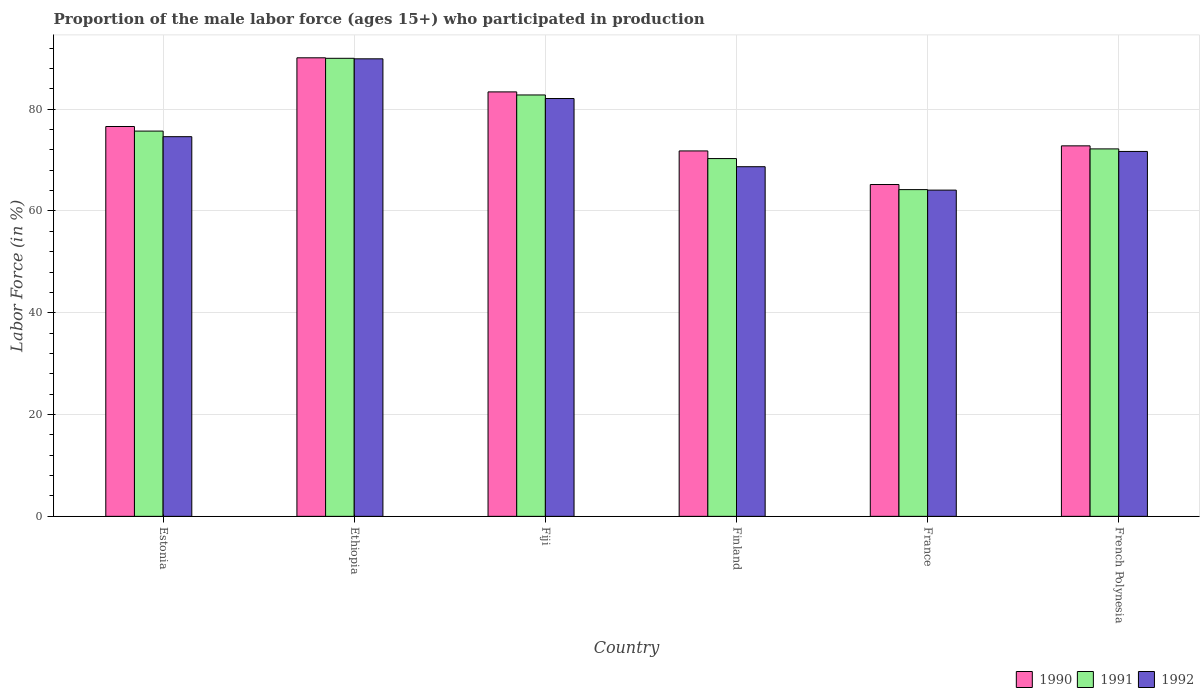What is the proportion of the male labor force who participated in production in 1991 in Finland?
Your answer should be very brief. 70.3. Across all countries, what is the maximum proportion of the male labor force who participated in production in 1992?
Your answer should be compact. 89.9. Across all countries, what is the minimum proportion of the male labor force who participated in production in 1992?
Your answer should be very brief. 64.1. In which country was the proportion of the male labor force who participated in production in 1992 maximum?
Give a very brief answer. Ethiopia. In which country was the proportion of the male labor force who participated in production in 1991 minimum?
Give a very brief answer. France. What is the total proportion of the male labor force who participated in production in 1992 in the graph?
Give a very brief answer. 451.1. What is the difference between the proportion of the male labor force who participated in production in 1990 in Fiji and that in Finland?
Your answer should be compact. 11.6. What is the difference between the proportion of the male labor force who participated in production in 1991 in Fiji and the proportion of the male labor force who participated in production in 1992 in French Polynesia?
Your answer should be compact. 11.1. What is the average proportion of the male labor force who participated in production in 1992 per country?
Offer a very short reply. 75.18. What is the difference between the proportion of the male labor force who participated in production of/in 1992 and proportion of the male labor force who participated in production of/in 1991 in France?
Your answer should be very brief. -0.1. In how many countries, is the proportion of the male labor force who participated in production in 1990 greater than 68 %?
Your answer should be very brief. 5. What is the ratio of the proportion of the male labor force who participated in production in 1990 in Ethiopia to that in Finland?
Your response must be concise. 1.25. Is the proportion of the male labor force who participated in production in 1990 in France less than that in French Polynesia?
Offer a terse response. Yes. Is the difference between the proportion of the male labor force who participated in production in 1992 in Fiji and French Polynesia greater than the difference between the proportion of the male labor force who participated in production in 1991 in Fiji and French Polynesia?
Keep it short and to the point. No. What is the difference between the highest and the second highest proportion of the male labor force who participated in production in 1991?
Ensure brevity in your answer.  14.3. What is the difference between the highest and the lowest proportion of the male labor force who participated in production in 1990?
Offer a terse response. 24.9. In how many countries, is the proportion of the male labor force who participated in production in 1991 greater than the average proportion of the male labor force who participated in production in 1991 taken over all countries?
Make the answer very short. 2. Is the sum of the proportion of the male labor force who participated in production in 1992 in Ethiopia and Finland greater than the maximum proportion of the male labor force who participated in production in 1990 across all countries?
Provide a succinct answer. Yes. What does the 2nd bar from the left in French Polynesia represents?
Give a very brief answer. 1991. What does the 2nd bar from the right in Estonia represents?
Ensure brevity in your answer.  1991. Is it the case that in every country, the sum of the proportion of the male labor force who participated in production in 1990 and proportion of the male labor force who participated in production in 1992 is greater than the proportion of the male labor force who participated in production in 1991?
Ensure brevity in your answer.  Yes. How many bars are there?
Keep it short and to the point. 18. Are the values on the major ticks of Y-axis written in scientific E-notation?
Offer a very short reply. No. Does the graph contain any zero values?
Keep it short and to the point. No. Where does the legend appear in the graph?
Make the answer very short. Bottom right. How are the legend labels stacked?
Make the answer very short. Horizontal. What is the title of the graph?
Provide a short and direct response. Proportion of the male labor force (ages 15+) who participated in production. What is the label or title of the X-axis?
Provide a short and direct response. Country. What is the label or title of the Y-axis?
Your response must be concise. Labor Force (in %). What is the Labor Force (in %) of 1990 in Estonia?
Offer a very short reply. 76.6. What is the Labor Force (in %) of 1991 in Estonia?
Offer a very short reply. 75.7. What is the Labor Force (in %) of 1992 in Estonia?
Your answer should be very brief. 74.6. What is the Labor Force (in %) in 1990 in Ethiopia?
Ensure brevity in your answer.  90.1. What is the Labor Force (in %) of 1991 in Ethiopia?
Offer a very short reply. 90. What is the Labor Force (in %) in 1992 in Ethiopia?
Offer a terse response. 89.9. What is the Labor Force (in %) of 1990 in Fiji?
Offer a terse response. 83.4. What is the Labor Force (in %) of 1991 in Fiji?
Offer a very short reply. 82.8. What is the Labor Force (in %) of 1992 in Fiji?
Make the answer very short. 82.1. What is the Labor Force (in %) in 1990 in Finland?
Make the answer very short. 71.8. What is the Labor Force (in %) in 1991 in Finland?
Ensure brevity in your answer.  70.3. What is the Labor Force (in %) in 1992 in Finland?
Give a very brief answer. 68.7. What is the Labor Force (in %) of 1990 in France?
Your answer should be very brief. 65.2. What is the Labor Force (in %) in 1991 in France?
Offer a very short reply. 64.2. What is the Labor Force (in %) in 1992 in France?
Your response must be concise. 64.1. What is the Labor Force (in %) in 1990 in French Polynesia?
Your answer should be compact. 72.8. What is the Labor Force (in %) in 1991 in French Polynesia?
Ensure brevity in your answer.  72.2. What is the Labor Force (in %) in 1992 in French Polynesia?
Your answer should be compact. 71.7. Across all countries, what is the maximum Labor Force (in %) in 1990?
Offer a very short reply. 90.1. Across all countries, what is the maximum Labor Force (in %) in 1991?
Your answer should be compact. 90. Across all countries, what is the maximum Labor Force (in %) of 1992?
Give a very brief answer. 89.9. Across all countries, what is the minimum Labor Force (in %) of 1990?
Provide a short and direct response. 65.2. Across all countries, what is the minimum Labor Force (in %) of 1991?
Make the answer very short. 64.2. Across all countries, what is the minimum Labor Force (in %) in 1992?
Offer a very short reply. 64.1. What is the total Labor Force (in %) in 1990 in the graph?
Your answer should be very brief. 459.9. What is the total Labor Force (in %) of 1991 in the graph?
Make the answer very short. 455.2. What is the total Labor Force (in %) in 1992 in the graph?
Your response must be concise. 451.1. What is the difference between the Labor Force (in %) of 1990 in Estonia and that in Ethiopia?
Give a very brief answer. -13.5. What is the difference between the Labor Force (in %) of 1991 in Estonia and that in Ethiopia?
Your answer should be very brief. -14.3. What is the difference between the Labor Force (in %) in 1992 in Estonia and that in Ethiopia?
Your answer should be compact. -15.3. What is the difference between the Labor Force (in %) in 1990 in Estonia and that in Fiji?
Provide a short and direct response. -6.8. What is the difference between the Labor Force (in %) in 1992 in Estonia and that in Finland?
Your answer should be very brief. 5.9. What is the difference between the Labor Force (in %) in 1992 in Estonia and that in France?
Offer a very short reply. 10.5. What is the difference between the Labor Force (in %) in 1990 in Estonia and that in French Polynesia?
Provide a short and direct response. 3.8. What is the difference between the Labor Force (in %) in 1990 in Ethiopia and that in Fiji?
Your answer should be compact. 6.7. What is the difference between the Labor Force (in %) in 1990 in Ethiopia and that in Finland?
Make the answer very short. 18.3. What is the difference between the Labor Force (in %) in 1991 in Ethiopia and that in Finland?
Ensure brevity in your answer.  19.7. What is the difference between the Labor Force (in %) of 1992 in Ethiopia and that in Finland?
Provide a short and direct response. 21.2. What is the difference between the Labor Force (in %) of 1990 in Ethiopia and that in France?
Keep it short and to the point. 24.9. What is the difference between the Labor Force (in %) of 1991 in Ethiopia and that in France?
Your answer should be very brief. 25.8. What is the difference between the Labor Force (in %) of 1992 in Ethiopia and that in France?
Offer a very short reply. 25.8. What is the difference between the Labor Force (in %) in 1990 in Fiji and that in France?
Provide a short and direct response. 18.2. What is the difference between the Labor Force (in %) in 1991 in Fiji and that in France?
Keep it short and to the point. 18.6. What is the difference between the Labor Force (in %) in 1992 in Fiji and that in France?
Your answer should be very brief. 18. What is the difference between the Labor Force (in %) of 1990 in Fiji and that in French Polynesia?
Your answer should be very brief. 10.6. What is the difference between the Labor Force (in %) of 1992 in Fiji and that in French Polynesia?
Make the answer very short. 10.4. What is the difference between the Labor Force (in %) in 1990 in Finland and that in France?
Ensure brevity in your answer.  6.6. What is the difference between the Labor Force (in %) in 1991 in Finland and that in France?
Provide a succinct answer. 6.1. What is the difference between the Labor Force (in %) in 1990 in Finland and that in French Polynesia?
Keep it short and to the point. -1. What is the difference between the Labor Force (in %) in 1991 in Finland and that in French Polynesia?
Offer a very short reply. -1.9. What is the difference between the Labor Force (in %) in 1992 in Finland and that in French Polynesia?
Provide a short and direct response. -3. What is the difference between the Labor Force (in %) in 1991 in France and that in French Polynesia?
Give a very brief answer. -8. What is the difference between the Labor Force (in %) in 1990 in Estonia and the Labor Force (in %) in 1992 in Ethiopia?
Make the answer very short. -13.3. What is the difference between the Labor Force (in %) of 1991 in Estonia and the Labor Force (in %) of 1992 in Ethiopia?
Make the answer very short. -14.2. What is the difference between the Labor Force (in %) of 1991 in Estonia and the Labor Force (in %) of 1992 in Fiji?
Your response must be concise. -6.4. What is the difference between the Labor Force (in %) of 1990 in Estonia and the Labor Force (in %) of 1992 in Finland?
Your response must be concise. 7.9. What is the difference between the Labor Force (in %) of 1991 in Estonia and the Labor Force (in %) of 1992 in Finland?
Your answer should be compact. 7. What is the difference between the Labor Force (in %) of 1990 in Estonia and the Labor Force (in %) of 1992 in France?
Your answer should be compact. 12.5. What is the difference between the Labor Force (in %) of 1991 in Estonia and the Labor Force (in %) of 1992 in French Polynesia?
Give a very brief answer. 4. What is the difference between the Labor Force (in %) in 1990 in Ethiopia and the Labor Force (in %) in 1991 in Fiji?
Give a very brief answer. 7.3. What is the difference between the Labor Force (in %) of 1990 in Ethiopia and the Labor Force (in %) of 1991 in Finland?
Your answer should be compact. 19.8. What is the difference between the Labor Force (in %) in 1990 in Ethiopia and the Labor Force (in %) in 1992 in Finland?
Provide a succinct answer. 21.4. What is the difference between the Labor Force (in %) of 1991 in Ethiopia and the Labor Force (in %) of 1992 in Finland?
Your answer should be very brief. 21.3. What is the difference between the Labor Force (in %) of 1990 in Ethiopia and the Labor Force (in %) of 1991 in France?
Offer a terse response. 25.9. What is the difference between the Labor Force (in %) in 1990 in Ethiopia and the Labor Force (in %) in 1992 in France?
Ensure brevity in your answer.  26. What is the difference between the Labor Force (in %) of 1991 in Ethiopia and the Labor Force (in %) of 1992 in France?
Your response must be concise. 25.9. What is the difference between the Labor Force (in %) in 1990 in Fiji and the Labor Force (in %) in 1992 in Finland?
Offer a very short reply. 14.7. What is the difference between the Labor Force (in %) of 1990 in Fiji and the Labor Force (in %) of 1992 in France?
Your response must be concise. 19.3. What is the difference between the Labor Force (in %) in 1990 in Fiji and the Labor Force (in %) in 1992 in French Polynesia?
Ensure brevity in your answer.  11.7. What is the difference between the Labor Force (in %) in 1991 in Finland and the Labor Force (in %) in 1992 in France?
Your response must be concise. 6.2. What is the difference between the Labor Force (in %) in 1990 in Finland and the Labor Force (in %) in 1992 in French Polynesia?
Make the answer very short. 0.1. What is the difference between the Labor Force (in %) in 1990 in France and the Labor Force (in %) in 1992 in French Polynesia?
Make the answer very short. -6.5. What is the difference between the Labor Force (in %) in 1991 in France and the Labor Force (in %) in 1992 in French Polynesia?
Offer a very short reply. -7.5. What is the average Labor Force (in %) of 1990 per country?
Provide a succinct answer. 76.65. What is the average Labor Force (in %) in 1991 per country?
Make the answer very short. 75.87. What is the average Labor Force (in %) in 1992 per country?
Provide a succinct answer. 75.18. What is the difference between the Labor Force (in %) in 1990 and Labor Force (in %) in 1991 in Estonia?
Give a very brief answer. 0.9. What is the difference between the Labor Force (in %) of 1990 and Labor Force (in %) of 1992 in Estonia?
Your answer should be very brief. 2. What is the difference between the Labor Force (in %) in 1990 and Labor Force (in %) in 1991 in Ethiopia?
Offer a very short reply. 0.1. What is the difference between the Labor Force (in %) in 1990 and Labor Force (in %) in 1992 in Ethiopia?
Make the answer very short. 0.2. What is the difference between the Labor Force (in %) in 1991 and Labor Force (in %) in 1992 in Ethiopia?
Keep it short and to the point. 0.1. What is the difference between the Labor Force (in %) of 1990 and Labor Force (in %) of 1991 in Fiji?
Offer a very short reply. 0.6. What is the difference between the Labor Force (in %) in 1991 and Labor Force (in %) in 1992 in Finland?
Make the answer very short. 1.6. What is the difference between the Labor Force (in %) in 1990 and Labor Force (in %) in 1991 in France?
Your response must be concise. 1. What is the difference between the Labor Force (in %) of 1990 and Labor Force (in %) of 1992 in French Polynesia?
Make the answer very short. 1.1. What is the ratio of the Labor Force (in %) in 1990 in Estonia to that in Ethiopia?
Provide a succinct answer. 0.85. What is the ratio of the Labor Force (in %) in 1991 in Estonia to that in Ethiopia?
Keep it short and to the point. 0.84. What is the ratio of the Labor Force (in %) in 1992 in Estonia to that in Ethiopia?
Your response must be concise. 0.83. What is the ratio of the Labor Force (in %) of 1990 in Estonia to that in Fiji?
Give a very brief answer. 0.92. What is the ratio of the Labor Force (in %) in 1991 in Estonia to that in Fiji?
Provide a short and direct response. 0.91. What is the ratio of the Labor Force (in %) of 1992 in Estonia to that in Fiji?
Keep it short and to the point. 0.91. What is the ratio of the Labor Force (in %) of 1990 in Estonia to that in Finland?
Offer a terse response. 1.07. What is the ratio of the Labor Force (in %) in 1991 in Estonia to that in Finland?
Your response must be concise. 1.08. What is the ratio of the Labor Force (in %) in 1992 in Estonia to that in Finland?
Your answer should be very brief. 1.09. What is the ratio of the Labor Force (in %) of 1990 in Estonia to that in France?
Provide a succinct answer. 1.17. What is the ratio of the Labor Force (in %) of 1991 in Estonia to that in France?
Your answer should be very brief. 1.18. What is the ratio of the Labor Force (in %) of 1992 in Estonia to that in France?
Offer a terse response. 1.16. What is the ratio of the Labor Force (in %) of 1990 in Estonia to that in French Polynesia?
Offer a terse response. 1.05. What is the ratio of the Labor Force (in %) of 1991 in Estonia to that in French Polynesia?
Provide a succinct answer. 1.05. What is the ratio of the Labor Force (in %) of 1992 in Estonia to that in French Polynesia?
Offer a terse response. 1.04. What is the ratio of the Labor Force (in %) of 1990 in Ethiopia to that in Fiji?
Offer a very short reply. 1.08. What is the ratio of the Labor Force (in %) in 1991 in Ethiopia to that in Fiji?
Keep it short and to the point. 1.09. What is the ratio of the Labor Force (in %) of 1992 in Ethiopia to that in Fiji?
Provide a short and direct response. 1.09. What is the ratio of the Labor Force (in %) in 1990 in Ethiopia to that in Finland?
Your answer should be very brief. 1.25. What is the ratio of the Labor Force (in %) in 1991 in Ethiopia to that in Finland?
Your answer should be compact. 1.28. What is the ratio of the Labor Force (in %) in 1992 in Ethiopia to that in Finland?
Your response must be concise. 1.31. What is the ratio of the Labor Force (in %) of 1990 in Ethiopia to that in France?
Give a very brief answer. 1.38. What is the ratio of the Labor Force (in %) of 1991 in Ethiopia to that in France?
Provide a succinct answer. 1.4. What is the ratio of the Labor Force (in %) of 1992 in Ethiopia to that in France?
Keep it short and to the point. 1.4. What is the ratio of the Labor Force (in %) in 1990 in Ethiopia to that in French Polynesia?
Your answer should be compact. 1.24. What is the ratio of the Labor Force (in %) of 1991 in Ethiopia to that in French Polynesia?
Your answer should be very brief. 1.25. What is the ratio of the Labor Force (in %) of 1992 in Ethiopia to that in French Polynesia?
Your answer should be compact. 1.25. What is the ratio of the Labor Force (in %) in 1990 in Fiji to that in Finland?
Keep it short and to the point. 1.16. What is the ratio of the Labor Force (in %) of 1991 in Fiji to that in Finland?
Your answer should be very brief. 1.18. What is the ratio of the Labor Force (in %) in 1992 in Fiji to that in Finland?
Provide a short and direct response. 1.2. What is the ratio of the Labor Force (in %) of 1990 in Fiji to that in France?
Your answer should be very brief. 1.28. What is the ratio of the Labor Force (in %) of 1991 in Fiji to that in France?
Provide a succinct answer. 1.29. What is the ratio of the Labor Force (in %) in 1992 in Fiji to that in France?
Keep it short and to the point. 1.28. What is the ratio of the Labor Force (in %) in 1990 in Fiji to that in French Polynesia?
Provide a short and direct response. 1.15. What is the ratio of the Labor Force (in %) of 1991 in Fiji to that in French Polynesia?
Offer a very short reply. 1.15. What is the ratio of the Labor Force (in %) in 1992 in Fiji to that in French Polynesia?
Your answer should be very brief. 1.15. What is the ratio of the Labor Force (in %) in 1990 in Finland to that in France?
Provide a succinct answer. 1.1. What is the ratio of the Labor Force (in %) of 1991 in Finland to that in France?
Offer a terse response. 1.09. What is the ratio of the Labor Force (in %) of 1992 in Finland to that in France?
Keep it short and to the point. 1.07. What is the ratio of the Labor Force (in %) in 1990 in Finland to that in French Polynesia?
Keep it short and to the point. 0.99. What is the ratio of the Labor Force (in %) in 1991 in Finland to that in French Polynesia?
Make the answer very short. 0.97. What is the ratio of the Labor Force (in %) in 1992 in Finland to that in French Polynesia?
Provide a succinct answer. 0.96. What is the ratio of the Labor Force (in %) of 1990 in France to that in French Polynesia?
Offer a terse response. 0.9. What is the ratio of the Labor Force (in %) of 1991 in France to that in French Polynesia?
Make the answer very short. 0.89. What is the ratio of the Labor Force (in %) of 1992 in France to that in French Polynesia?
Your response must be concise. 0.89. What is the difference between the highest and the second highest Labor Force (in %) in 1990?
Your answer should be compact. 6.7. What is the difference between the highest and the second highest Labor Force (in %) in 1991?
Your answer should be compact. 7.2. What is the difference between the highest and the lowest Labor Force (in %) in 1990?
Ensure brevity in your answer.  24.9. What is the difference between the highest and the lowest Labor Force (in %) in 1991?
Your response must be concise. 25.8. What is the difference between the highest and the lowest Labor Force (in %) of 1992?
Keep it short and to the point. 25.8. 